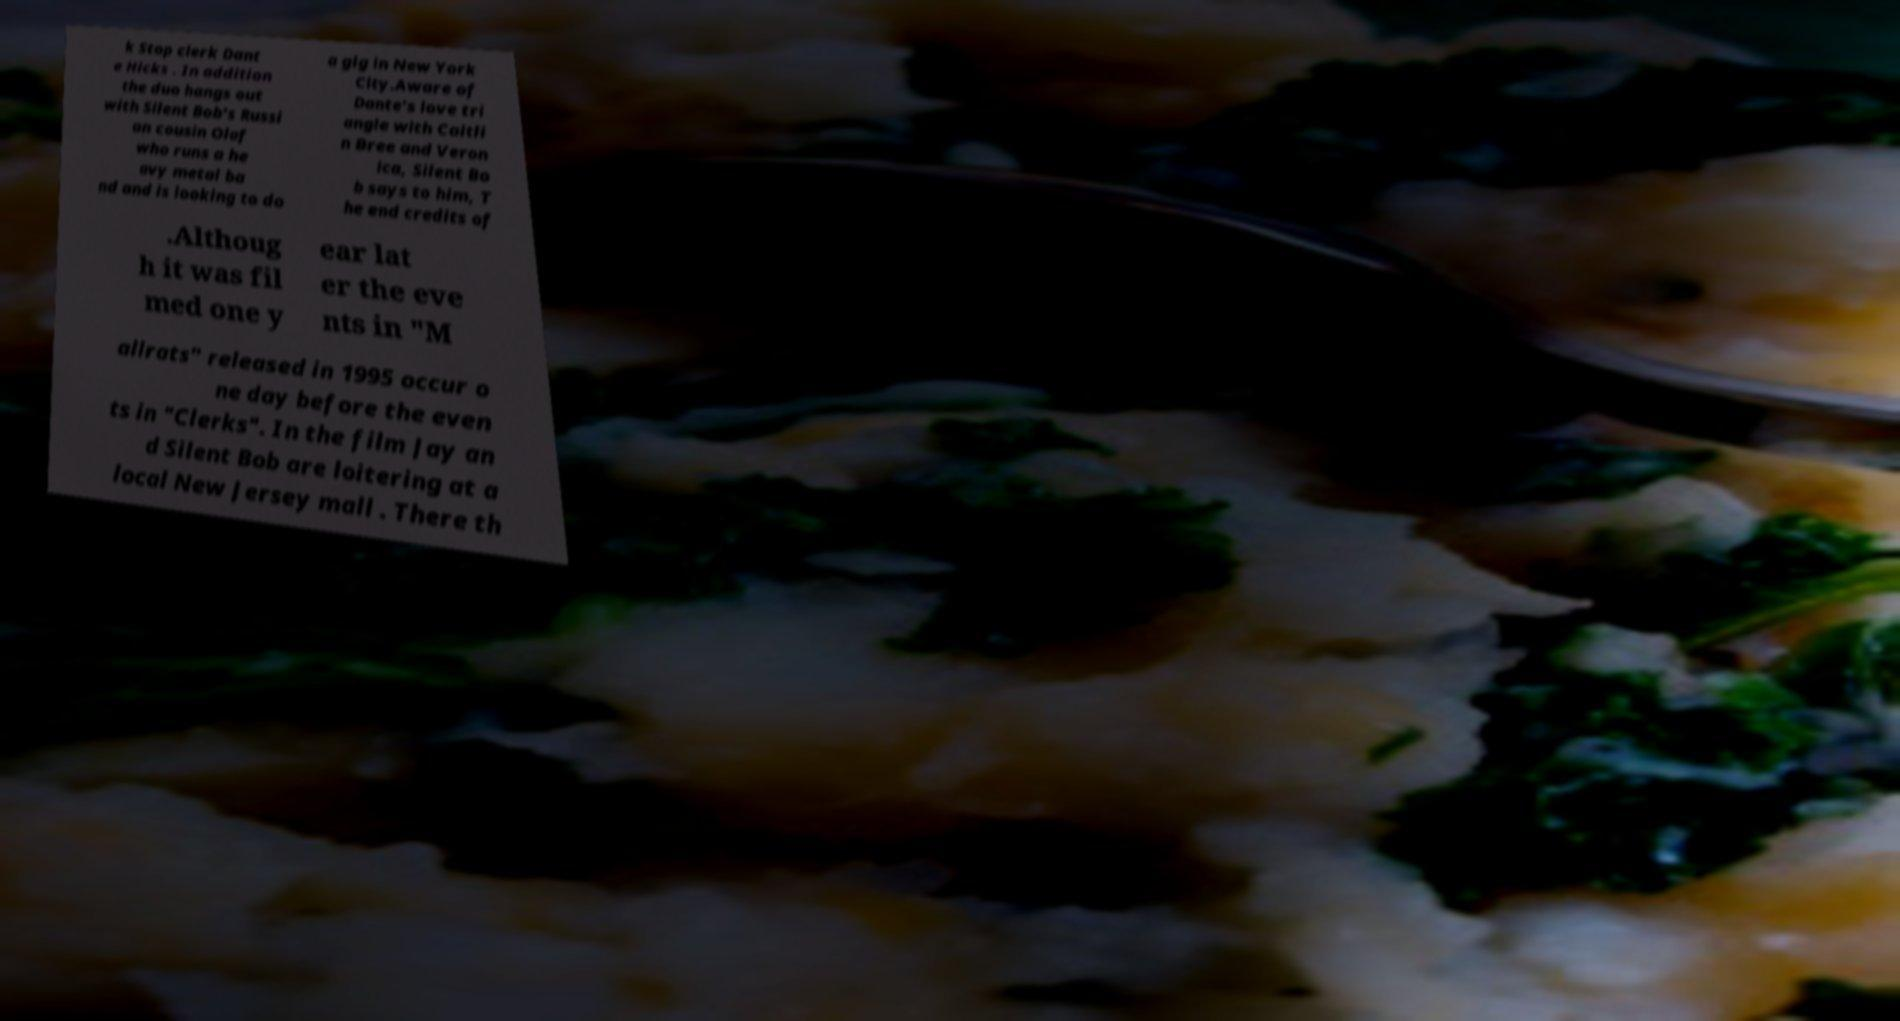There's text embedded in this image that I need extracted. Can you transcribe it verbatim? k Stop clerk Dant e Hicks . In addition the duo hangs out with Silent Bob's Russi an cousin Olaf who runs a he avy metal ba nd and is looking to do a gig in New York City.Aware of Dante's love tri angle with Caitli n Bree and Veron ica, Silent Bo b says to him, T he end credits of .Althoug h it was fil med one y ear lat er the eve nts in "M allrats" released in 1995 occur o ne day before the even ts in "Clerks". In the film Jay an d Silent Bob are loitering at a local New Jersey mall . There th 